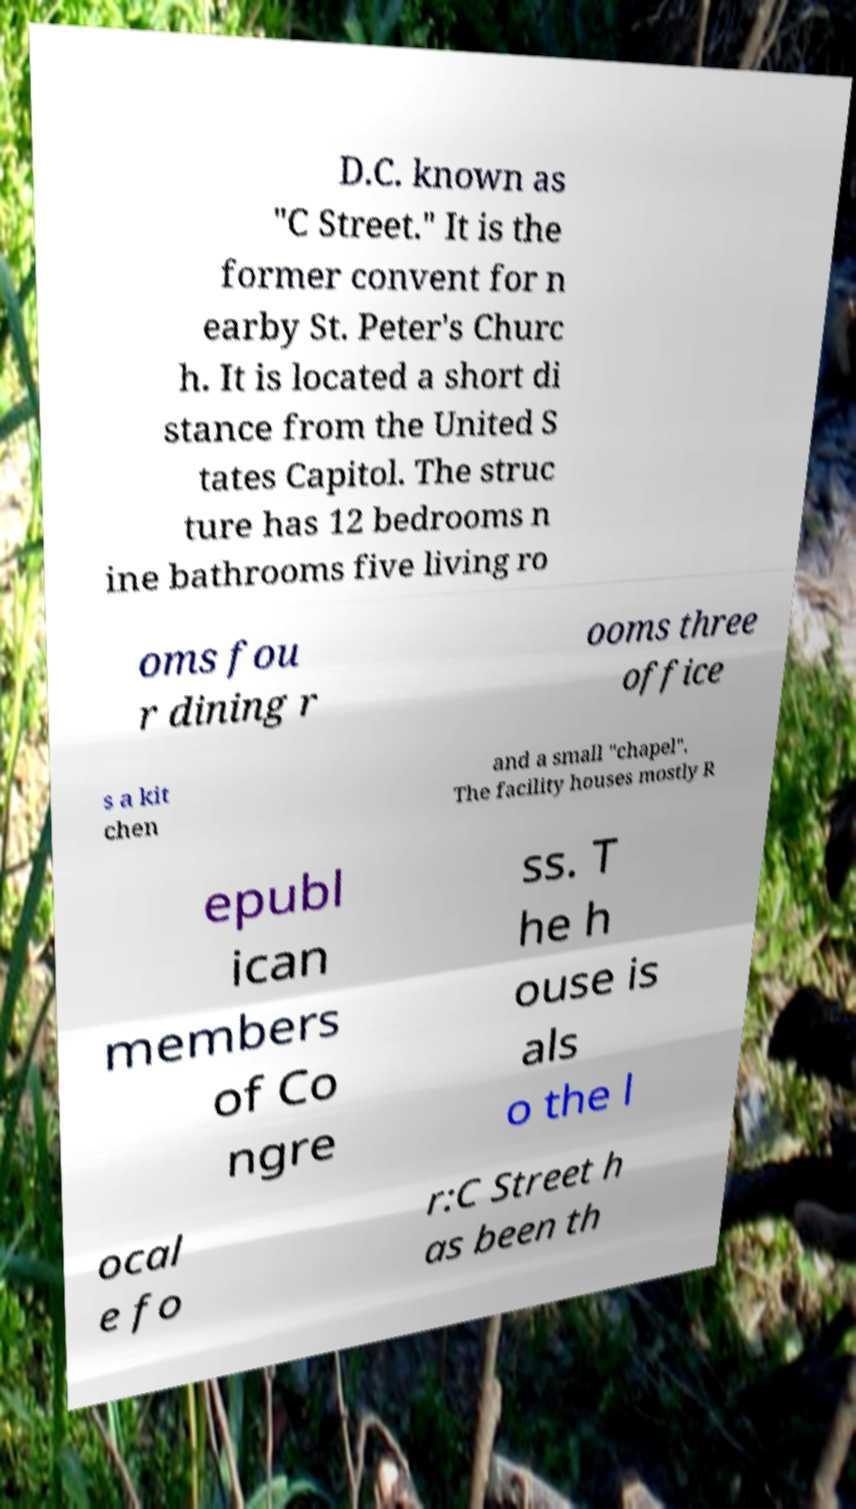For documentation purposes, I need the text within this image transcribed. Could you provide that? D.C. known as "C Street." It is the former convent for n earby St. Peter's Churc h. It is located a short di stance from the United S tates Capitol. The struc ture has 12 bedrooms n ine bathrooms five living ro oms fou r dining r ooms three office s a kit chen and a small "chapel". The facility houses mostly R epubl ican members of Co ngre ss. T he h ouse is als o the l ocal e fo r:C Street h as been th 